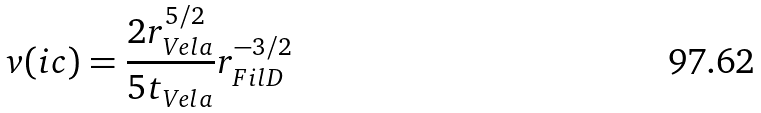Convert formula to latex. <formula><loc_0><loc_0><loc_500><loc_500>v ( i c ) = \frac { 2 r _ { V e l a } ^ { 5 / 2 } } { 5 t _ { V e l a } } r _ { F i l D } ^ { - 3 / 2 }</formula> 